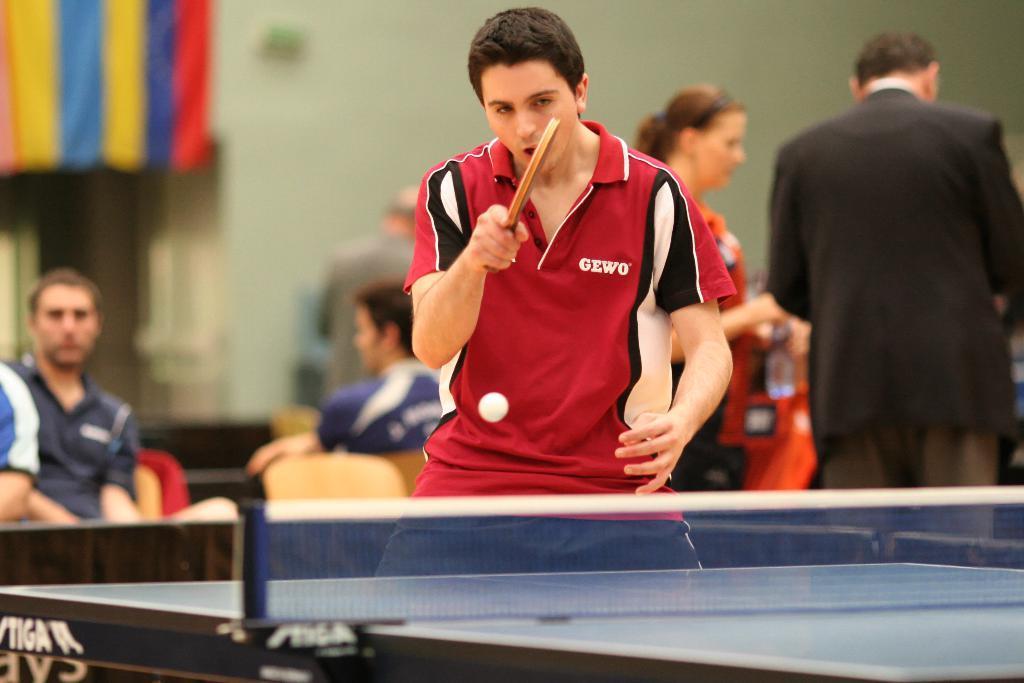Could you give a brief overview of what you see in this image? In the center of the image we can see a man standing holding a racket. We can also see a ball and the table tennis in front of him. On the backside we can see some people standing. In that a woman is holding a bottle. We can also see some people sitting on the chairs, a cloth and a wall. 